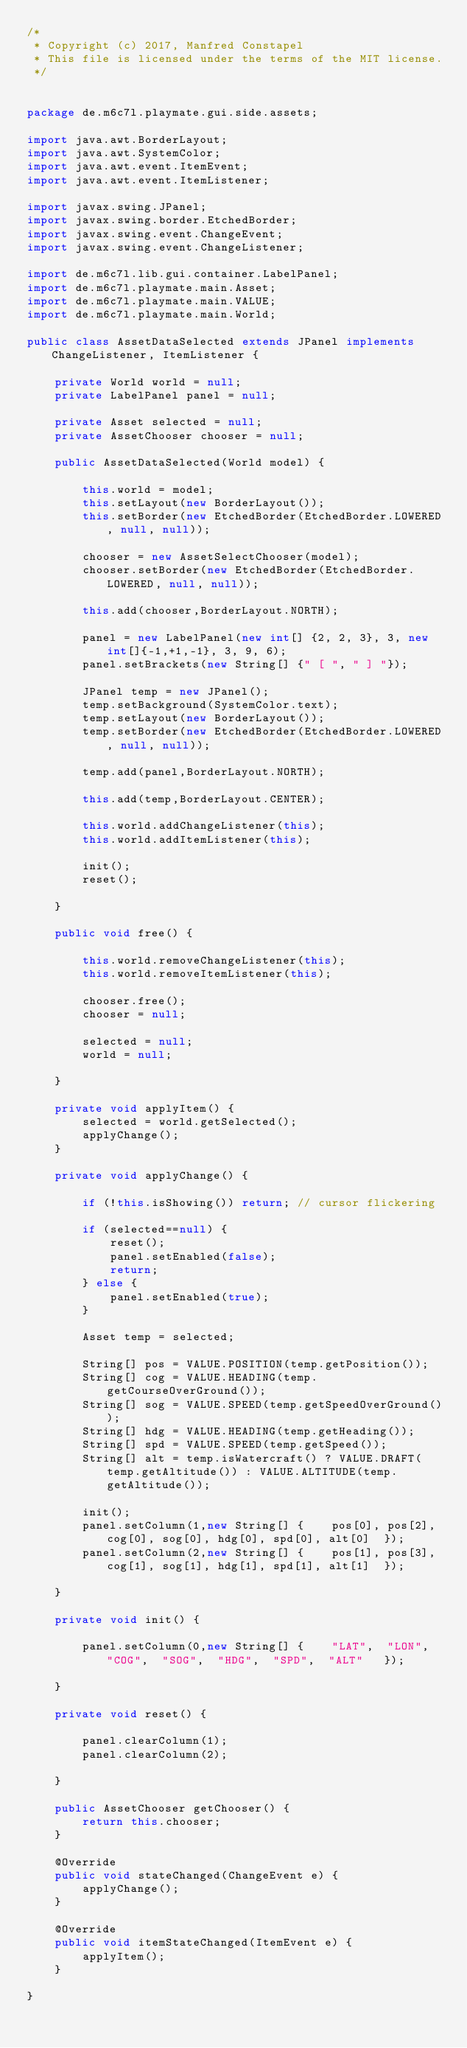Convert code to text. <code><loc_0><loc_0><loc_500><loc_500><_Java_>/*
 * Copyright (c) 2017, Manfred Constapel
 * This file is licensed under the terms of the MIT license.
 */


package de.m6c7l.playmate.gui.side.assets;

import java.awt.BorderLayout;
import java.awt.SystemColor;
import java.awt.event.ItemEvent;
import java.awt.event.ItemListener;

import javax.swing.JPanel;
import javax.swing.border.EtchedBorder;
import javax.swing.event.ChangeEvent;
import javax.swing.event.ChangeListener;

import de.m6c7l.lib.gui.container.LabelPanel;
import de.m6c7l.playmate.main.Asset;
import de.m6c7l.playmate.main.VALUE;
import de.m6c7l.playmate.main.World;

public class AssetDataSelected extends JPanel implements ChangeListener, ItemListener {
	
	private World world = null;
	private LabelPanel panel = null;
	
	private Asset selected = null;
	private AssetChooser chooser = null;
	
	public AssetDataSelected(World model) {

		this.world = model;
		this.setLayout(new BorderLayout());
		this.setBorder(new EtchedBorder(EtchedBorder.LOWERED, null, null));
		
		chooser = new AssetSelectChooser(model);
		chooser.setBorder(new EtchedBorder(EtchedBorder.LOWERED, null, null));
		
		this.add(chooser,BorderLayout.NORTH);
		
		panel = new LabelPanel(new int[] {2, 2, 3}, 3, new int[]{-1,+1,-1}, 3, 9, 6);
		panel.setBrackets(new String[] {" [ ", " ] "});
		
		JPanel temp = new JPanel();
		temp.setBackground(SystemColor.text);
		temp.setLayout(new BorderLayout());
		temp.setBorder(new EtchedBorder(EtchedBorder.LOWERED, null, null));

		temp.add(panel,BorderLayout.NORTH);
		
		this.add(temp,BorderLayout.CENTER);
		
		this.world.addChangeListener(this);
		this.world.addItemListener(this);
		
		init();
		reset();

	}
	
	public void free() {
		
		this.world.removeChangeListener(this);
		this.world.removeItemListener(this);
		
		chooser.free();
		chooser = null;
		
		selected = null;
		world = null;
		
	}
	
	private void applyItem() {
		selected = world.getSelected();
		applyChange();
	}
		
	private void applyChange() {

		if (!this.isShowing()) return; // cursor flickering
		
		if (selected==null) {
			reset();
			panel.setEnabled(false);
			return;
		} else {
			panel.setEnabled(true);						
		}		
		
		Asset temp = selected;
		
		String[] pos = VALUE.POSITION(temp.getPosition());
		String[] cog = VALUE.HEADING(temp.getCourseOverGround());
		String[] sog = VALUE.SPEED(temp.getSpeedOverGround());
		String[] hdg = VALUE.HEADING(temp.getHeading());
		String[] spd = VALUE.SPEED(temp.getSpeed());
		String[] alt = temp.isWatercraft() ? VALUE.DRAFT(temp.getAltitude()) : VALUE.ALTITUDE(temp.getAltitude());
		
		init();
		panel.setColumn(1,new String[] { 	pos[0],	pos[2],	cog[0],	sog[0],	hdg[0],	spd[0],	alt[0]	});
		panel.setColumn(2,new String[] { 	pos[1],	pos[3],	cog[1],	sog[1],	hdg[1],	spd[1],	alt[1]	});
		
	}
	
	private void init() {
		
		panel.setColumn(0,new String[] {	"LAT",	"LON",	"COG",	"SOG",	"HDG",	"SPD",	"ALT"	});	
		
	}
	
	private void reset() {

		panel.clearColumn(1);
		panel.clearColumn(2);
		
	}
	
	public AssetChooser getChooser() {
		return this.chooser;
	}
	
	@Override
	public void stateChanged(ChangeEvent e) {
		applyChange();
	}

	@Override
	public void itemStateChanged(ItemEvent e) {
		applyItem();
	}

}
</code> 